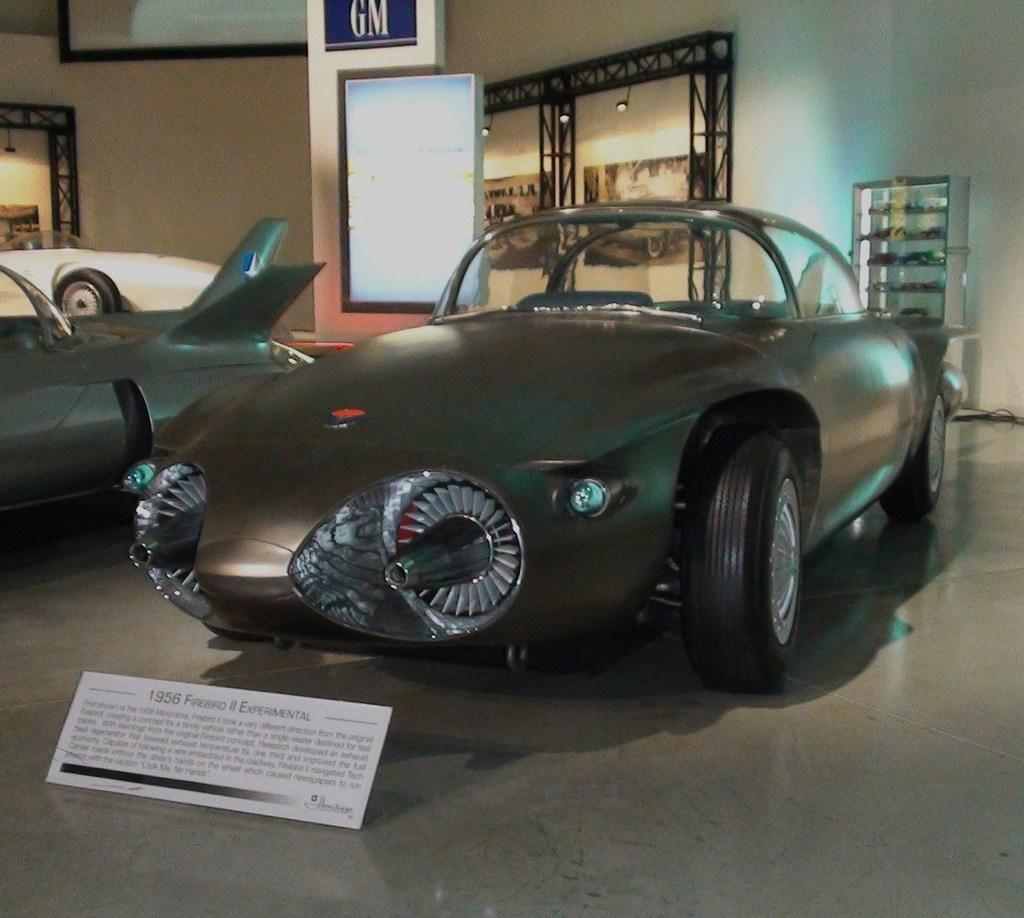What types of objects can be seen in the image? There are vehicles and a name board visible in the image. What can be found in the background of the image? In the background, there are frames, another name board, lights, iron objects, a wall, and other objects. What type of string is being used to hold the comb in the image? There is no string or comb present in the image. 